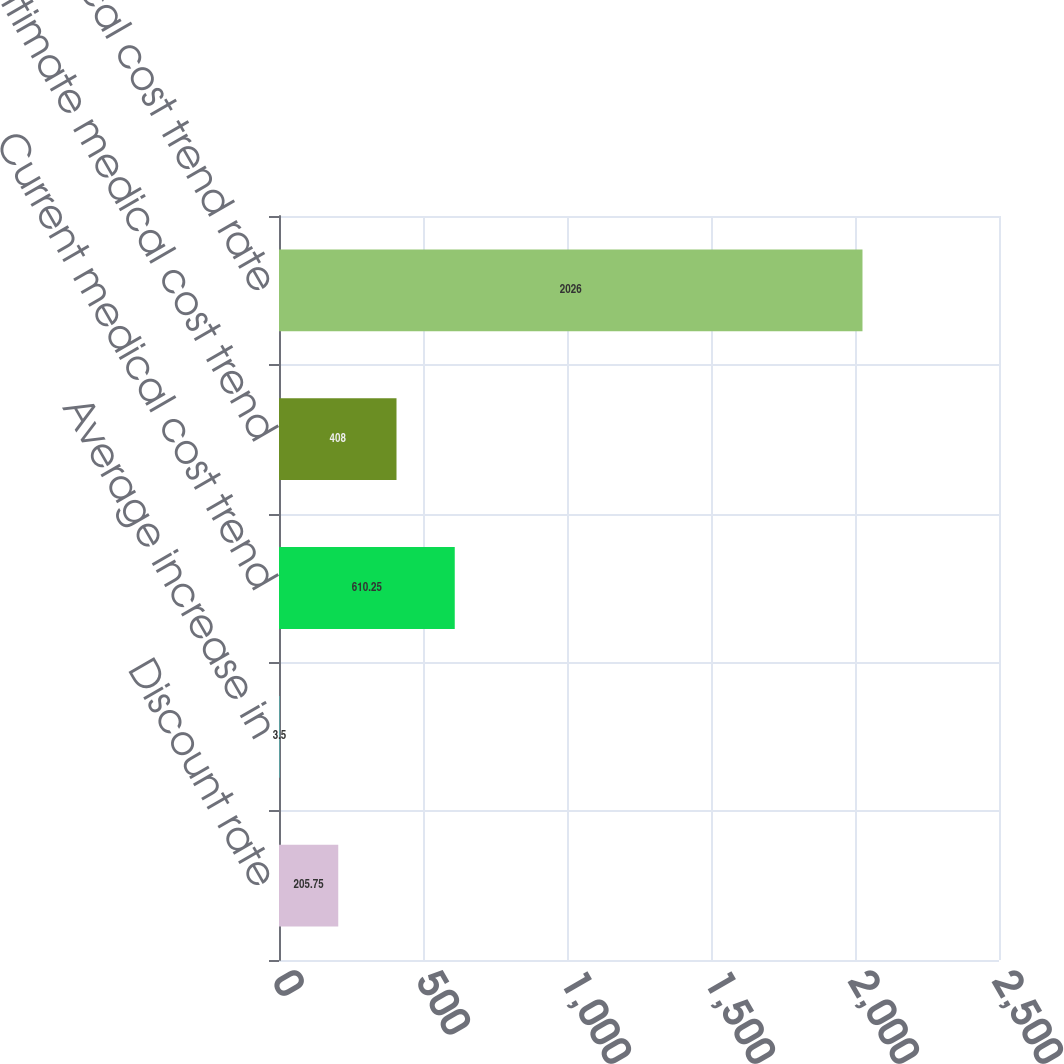Convert chart to OTSL. <chart><loc_0><loc_0><loc_500><loc_500><bar_chart><fcel>Discount rate<fcel>Average increase in<fcel>Current medical cost trend<fcel>Ultimate medical cost trend<fcel>Medical cost trend rate<nl><fcel>205.75<fcel>3.5<fcel>610.25<fcel>408<fcel>2026<nl></chart> 